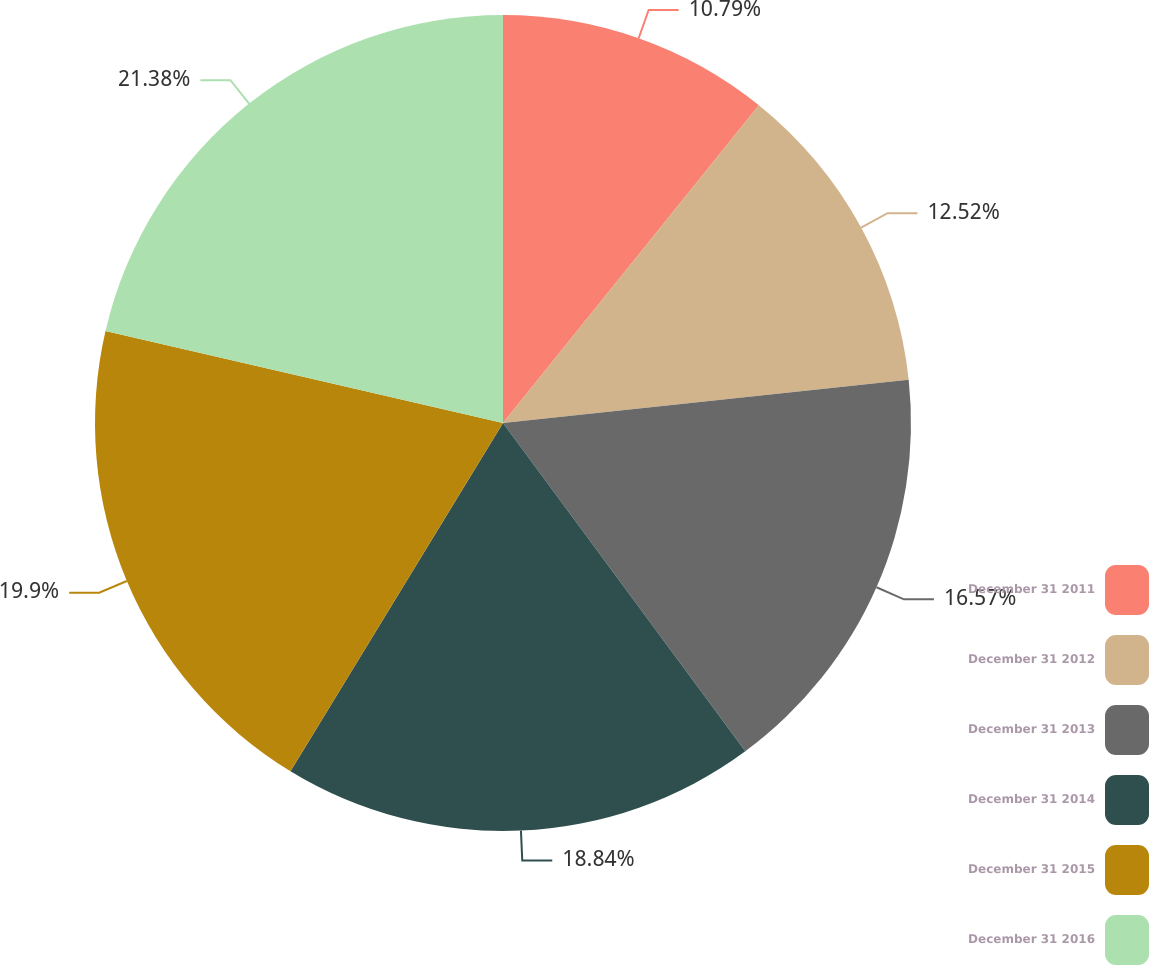<chart> <loc_0><loc_0><loc_500><loc_500><pie_chart><fcel>December 31 2011<fcel>December 31 2012<fcel>December 31 2013<fcel>December 31 2014<fcel>December 31 2015<fcel>December 31 2016<nl><fcel>10.79%<fcel>12.52%<fcel>16.57%<fcel>18.84%<fcel>19.9%<fcel>21.38%<nl></chart> 